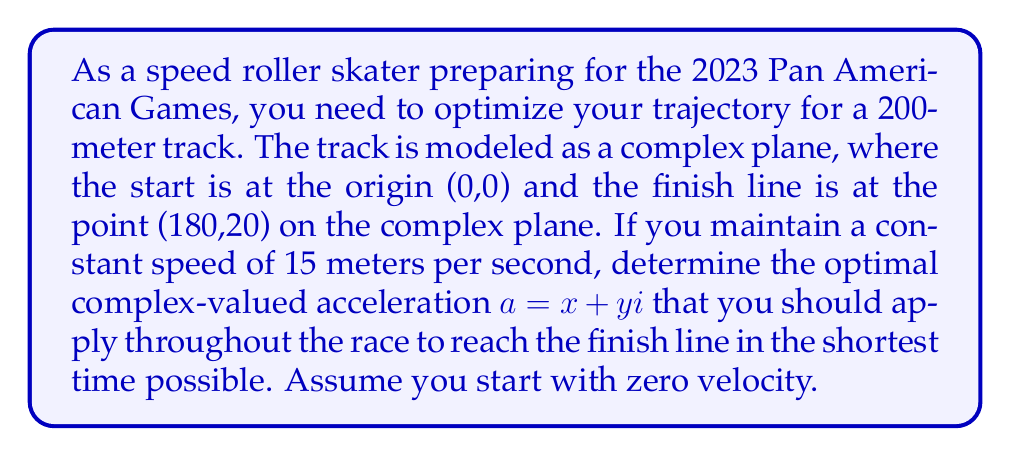Teach me how to tackle this problem. Let's approach this step-by-step using complex number representation:

1) First, we need to represent the finish line position as a complex number:
   $z_f = 180 + 20i$

2) The time to reach the finish line is given by:
   $t = \frac{\text{distance}}{\text{speed}} = \frac{|z_f|}{15}$

3) Calculate $|z_f|$:
   $|z_f| = \sqrt{180^2 + 20^2} = \sqrt{32800} \approx 181.11$ meters

4) Calculate time:
   $t = \frac{181.11}{15} \approx 12.074$ seconds

5) In complex plane kinematics, the position after time $t$ with constant acceleration $a$ is given by:
   $z(t) = \frac{1}{2}at^2$

6) Since we know $z(t) = z_f$ and $t$, we can solve for $a$:
   $z_f = \frac{1}{2}at^2$
   $a = \frac{2z_f}{t^2}$

7) Substituting the values:
   $a = \frac{2(180 + 20i)}{12.074^2}$

8) Simplify:
   $a \approx 2.4684 + 0.2743i$

Therefore, the optimal acceleration is approximately 2.4684 m/s² in the x-direction and 0.2743 m/s² in the y-direction.
Answer: $a \approx 2.4684 + 0.2743i$ m/s² 